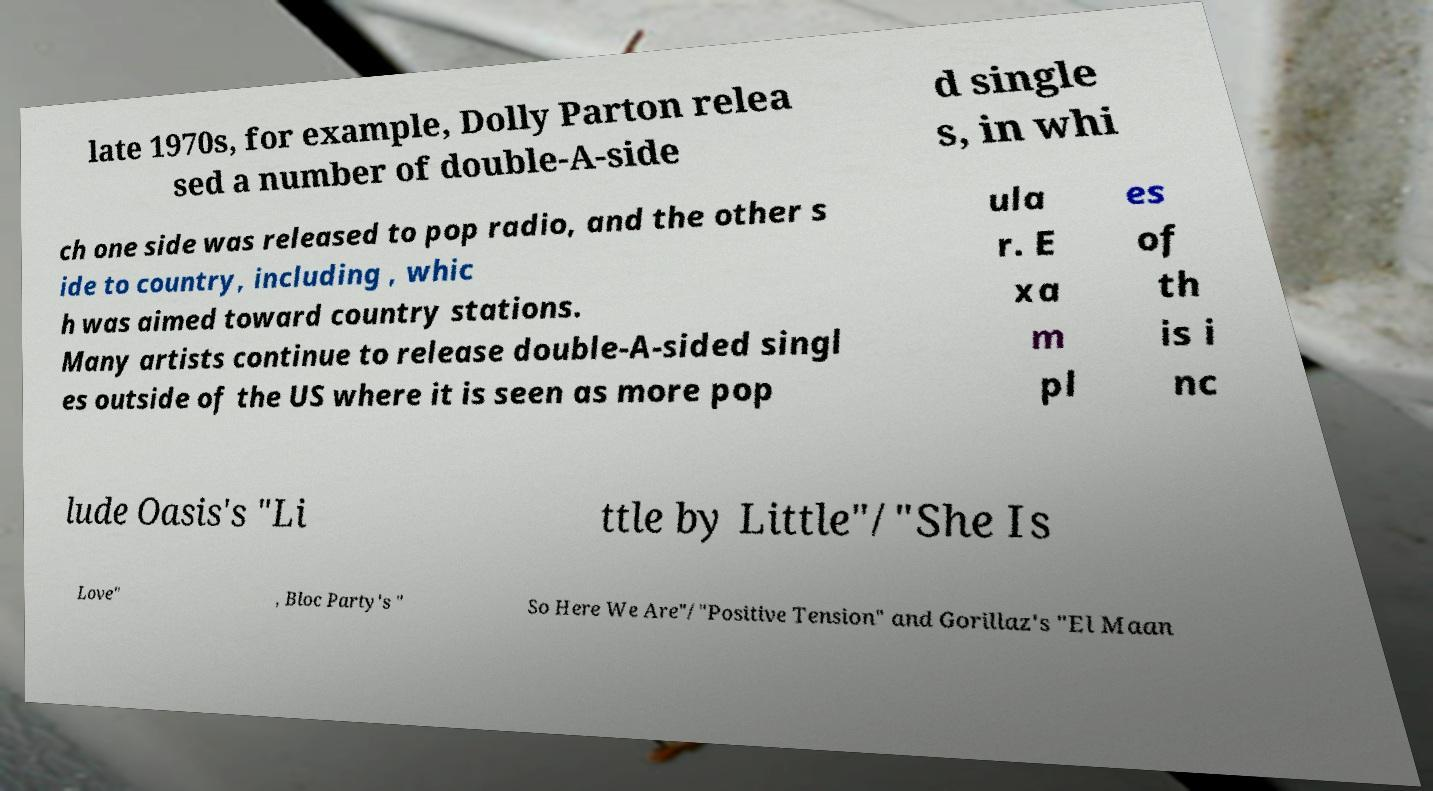What messages or text are displayed in this image? I need them in a readable, typed format. late 1970s, for example, Dolly Parton relea sed a number of double-A-side d single s, in whi ch one side was released to pop radio, and the other s ide to country, including , whic h was aimed toward country stations. Many artists continue to release double-A-sided singl es outside of the US where it is seen as more pop ula r. E xa m pl es of th is i nc lude Oasis's "Li ttle by Little"/"She Is Love" , Bloc Party's " So Here We Are"/"Positive Tension" and Gorillaz's "El Maan 